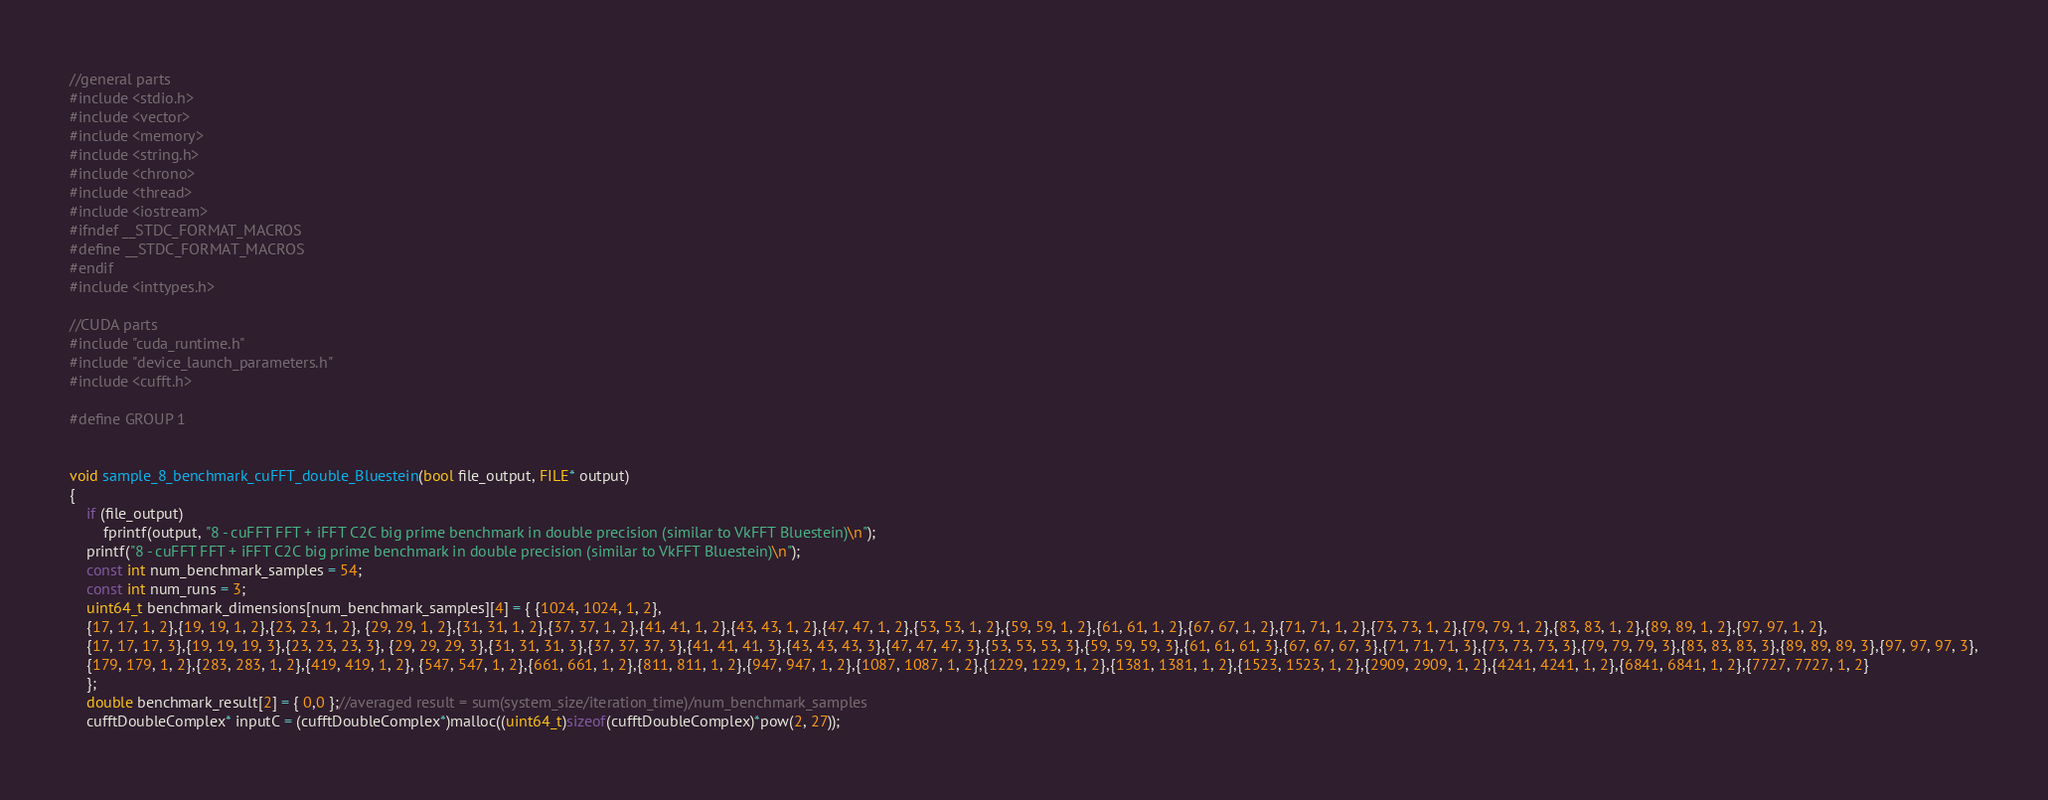Convert code to text. <code><loc_0><loc_0><loc_500><loc_500><_Cuda_>//general parts
#include <stdio.h>
#include <vector>
#include <memory>
#include <string.h>
#include <chrono>
#include <thread>
#include <iostream>
#ifndef __STDC_FORMAT_MACROS
#define __STDC_FORMAT_MACROS
#endif
#include <inttypes.h>

//CUDA parts
#include "cuda_runtime.h"
#include "device_launch_parameters.h"
#include <cufft.h>

#define GROUP 1


void sample_8_benchmark_cuFFT_double_Bluestein(bool file_output, FILE* output)
{
	if (file_output)
		fprintf(output, "8 - cuFFT FFT + iFFT C2C big prime benchmark in double precision (similar to VkFFT Bluestein)\n");
	printf("8 - cuFFT FFT + iFFT C2C big prime benchmark in double precision (similar to VkFFT Bluestein)\n");
	const int num_benchmark_samples = 54;
	const int num_runs = 3;
	uint64_t benchmark_dimensions[num_benchmark_samples][4] = { {1024, 1024, 1, 2},
	{17, 17, 1, 2},{19, 19, 1, 2},{23, 23, 1, 2}, {29, 29, 1, 2},{31, 31, 1, 2},{37, 37, 1, 2},{41, 41, 1, 2},{43, 43, 1, 2},{47, 47, 1, 2},{53, 53, 1, 2},{59, 59, 1, 2},{61, 61, 1, 2},{67, 67, 1, 2},{71, 71, 1, 2},{73, 73, 1, 2},{79, 79, 1, 2},{83, 83, 1, 2},{89, 89, 1, 2},{97, 97, 1, 2},
	{17, 17, 17, 3},{19, 19, 19, 3},{23, 23, 23, 3}, {29, 29, 29, 3},{31, 31, 31, 3},{37, 37, 37, 3},{41, 41, 41, 3},{43, 43, 43, 3},{47, 47, 47, 3},{53, 53, 53, 3},{59, 59, 59, 3},{61, 61, 61, 3},{67, 67, 67, 3},{71, 71, 71, 3},{73, 73, 73, 3},{79, 79, 79, 3},{83, 83, 83, 3},{89, 89, 89, 3},{97, 97, 97, 3},
	{179, 179, 1, 2},{283, 283, 1, 2},{419, 419, 1, 2}, {547, 547, 1, 2},{661, 661, 1, 2},{811, 811, 1, 2},{947, 947, 1, 2},{1087, 1087, 1, 2},{1229, 1229, 1, 2},{1381, 1381, 1, 2},{1523, 1523, 1, 2},{2909, 2909, 1, 2},{4241, 4241, 1, 2},{6841, 6841, 1, 2},{7727, 7727, 1, 2}
	};
	double benchmark_result[2] = { 0,0 };//averaged result = sum(system_size/iteration_time)/num_benchmark_samples
	cufftDoubleComplex* inputC = (cufftDoubleComplex*)malloc((uint64_t)sizeof(cufftDoubleComplex)*pow(2, 27));</code> 